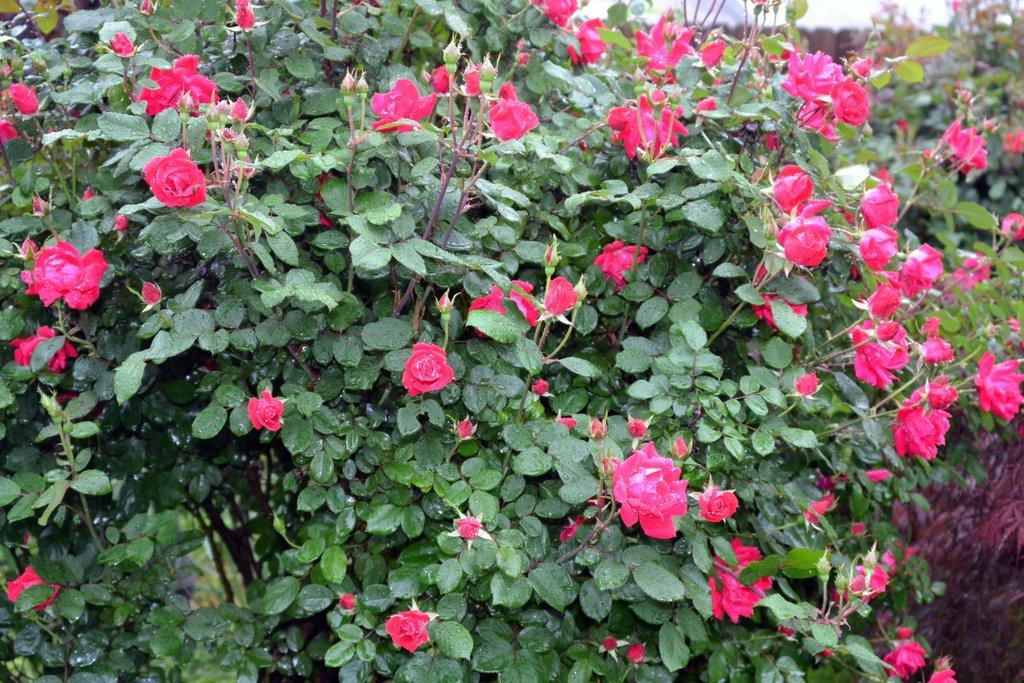What is the color of the plant in the image? The plant is green. What type of flowers are on the plant? The plant has red roses. How many mountains can be seen in the image? There are no mountains present in the image; it features a plant with red roses. What type of spacecraft is visible in the image? There is no spacecraft present in the image; it features a plant with red roses. 